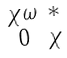<formula> <loc_0><loc_0><loc_500><loc_500>\begin{smallmatrix} \chi \omega & \ast \\ 0 & \chi \end{smallmatrix}</formula> 